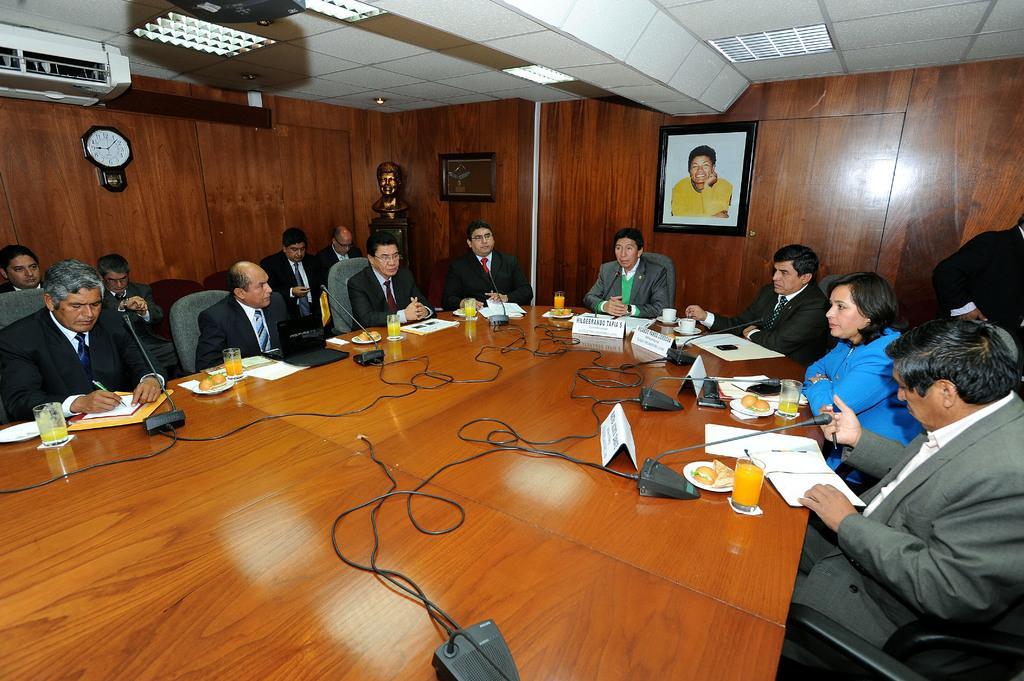Describe this image in one or two sentences. In this image I can see a group of people are sitting on the chairs in front of a table on which I can see glasses, boards, wires and mike's. In the background I can see a wooden wall, wall clock, photo frame and a rooftop on which lights are mounted. This image is taken may be in a hall. 